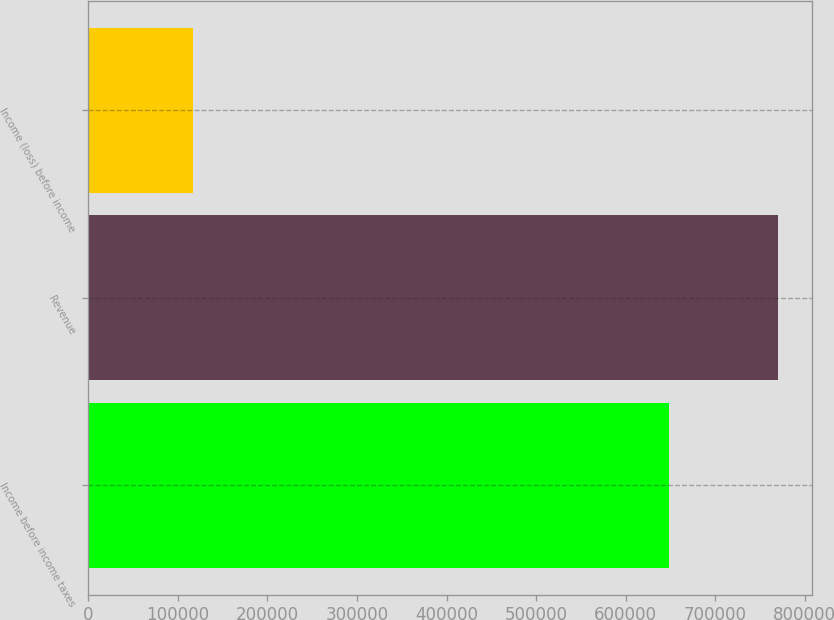<chart> <loc_0><loc_0><loc_500><loc_500><bar_chart><fcel>Income before income taxes<fcel>Revenue<fcel>Income (loss) before income<nl><fcel>648740<fcel>770190<fcel>117199<nl></chart> 